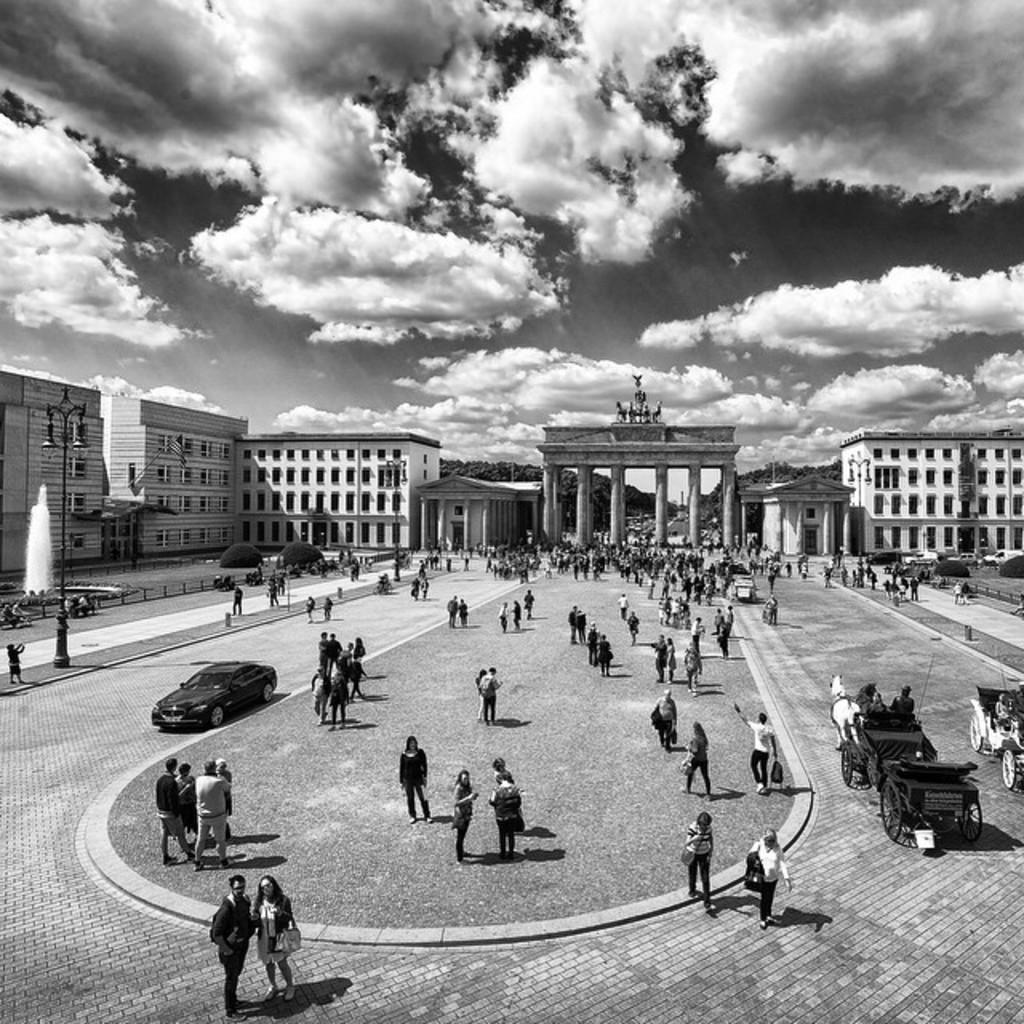What type of structures can be seen in the image? There are buildings in the image. What architectural features are present in the image? There are windows, light poles, and an arch in the image. What natural elements are visible in the image? There are trees in the image. What man-made objects can be seen in the image? There are vehicles in the image. What type of water feature is present in the image? There is a fountain in the image. What is the color scheme of the image? The image is in black and white. Are there any living beings present in the image? Yes, there are people in the image. Where is the pot located in the image? There is no pot present in the image. What type of throne can be seen in the image? There is no throne present in the image. 